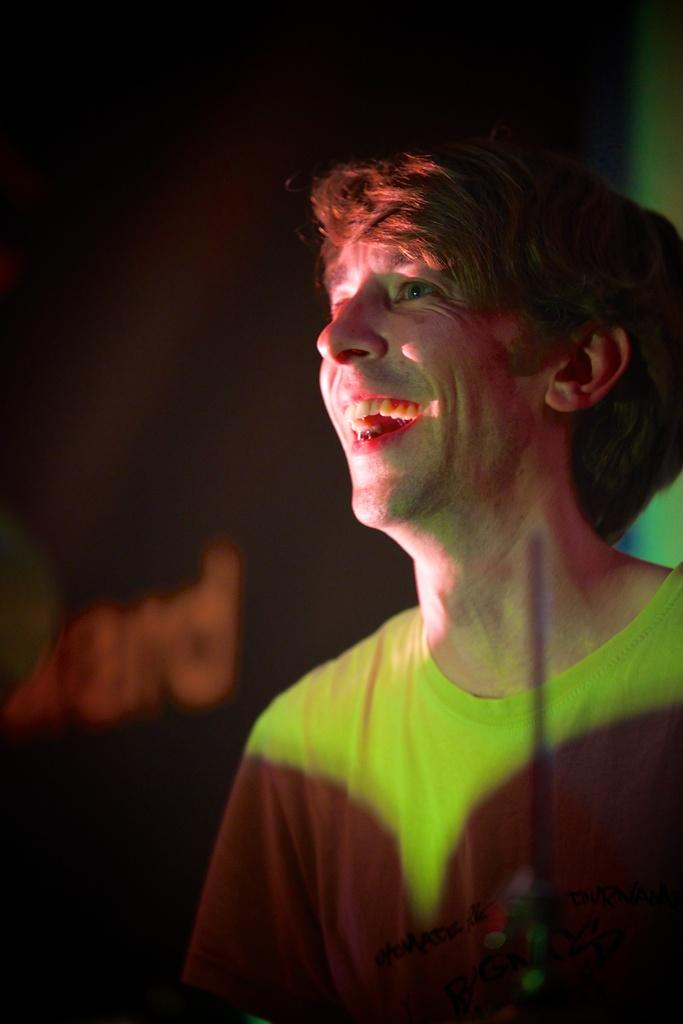What is the main subject of the image? The main subject of the image is a boy. What is the boy wearing in the image? The boy is wearing a yellow t-shirt in the image. Where is the boy positioned in the image? The boy is standing in the front in the image. What is the boy's facial expression in the image? The boy is smiling in the image. What direction is the boy looking in the image? The boy is looking to the left side in the image. What can be seen in the background of the image? The background of the image is dark. What type of celery is the boy holding in the image? There is no celery present in the image; the boy is not holding any celery. What kind of doctor is standing next to the boy in the image? There is no doctor present in the image; the boy is the only person visible. 